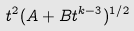Convert formula to latex. <formula><loc_0><loc_0><loc_500><loc_500>t ^ { 2 } ( A + B t ^ { k - 3 } ) ^ { 1 / 2 }</formula> 